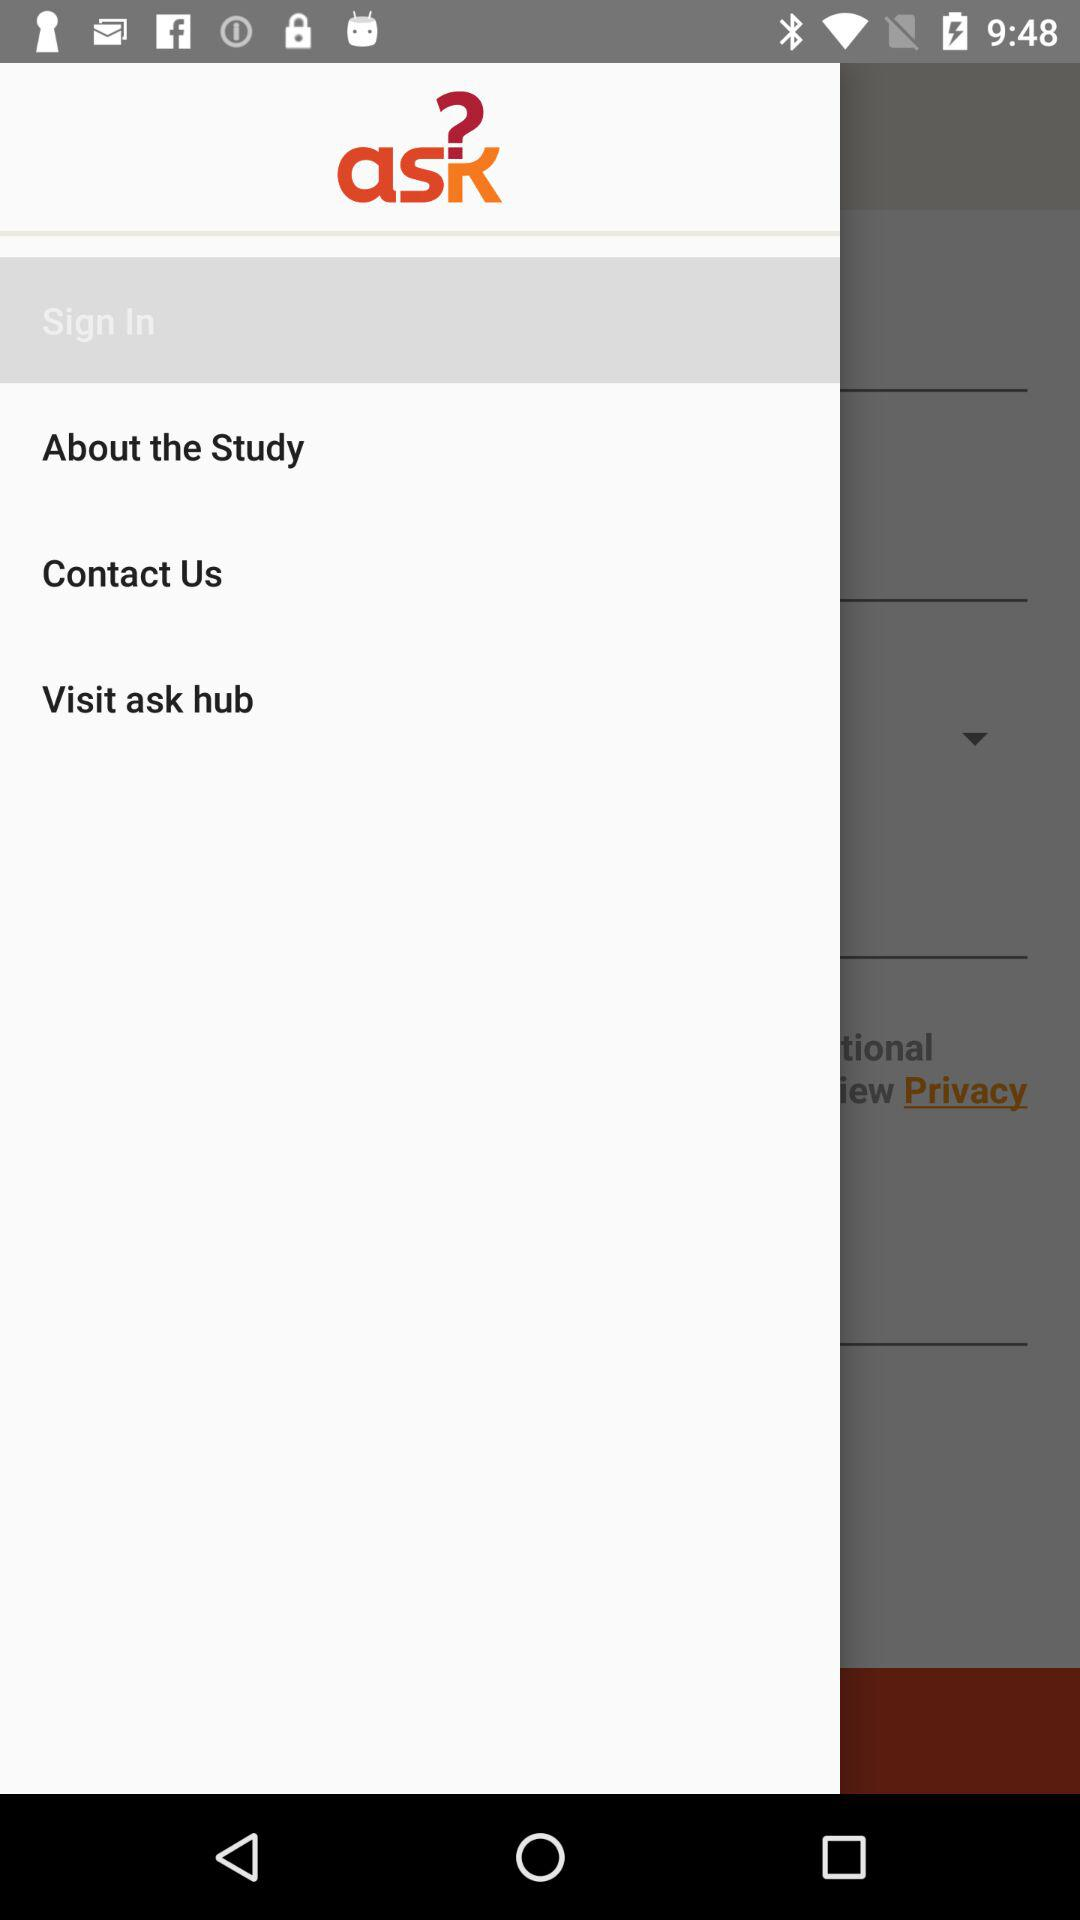What is the name of the application? The name of the application is "ask". 